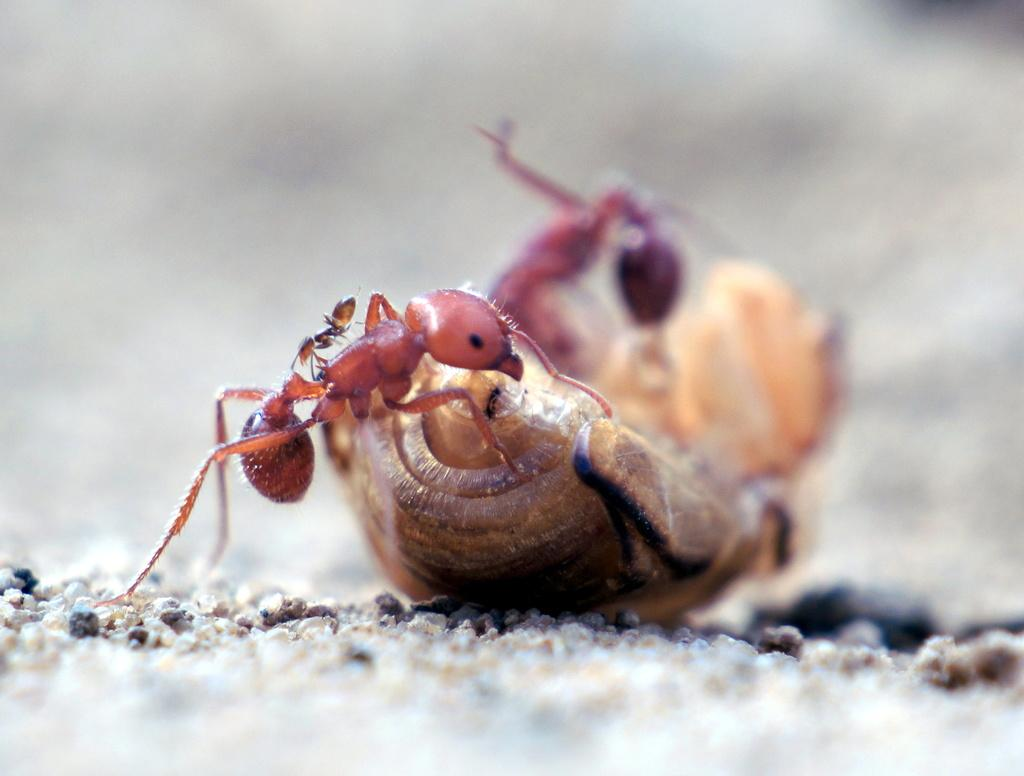What type of creatures can be seen in the image? There are ants and an insect in the image. Where are the ants and insect located? They are on the sand in the image. How are the edges of the image presented? The top and bottom of the image are blurred. How many visitors are sitting on the swing in the image? There is no swing present in the image; it features ants and an insect on the sand. What type of acoustics can be heard from the ants in the image? Ants do not produce sounds that can be heard, so there is no acoustics associated with them in the image. 